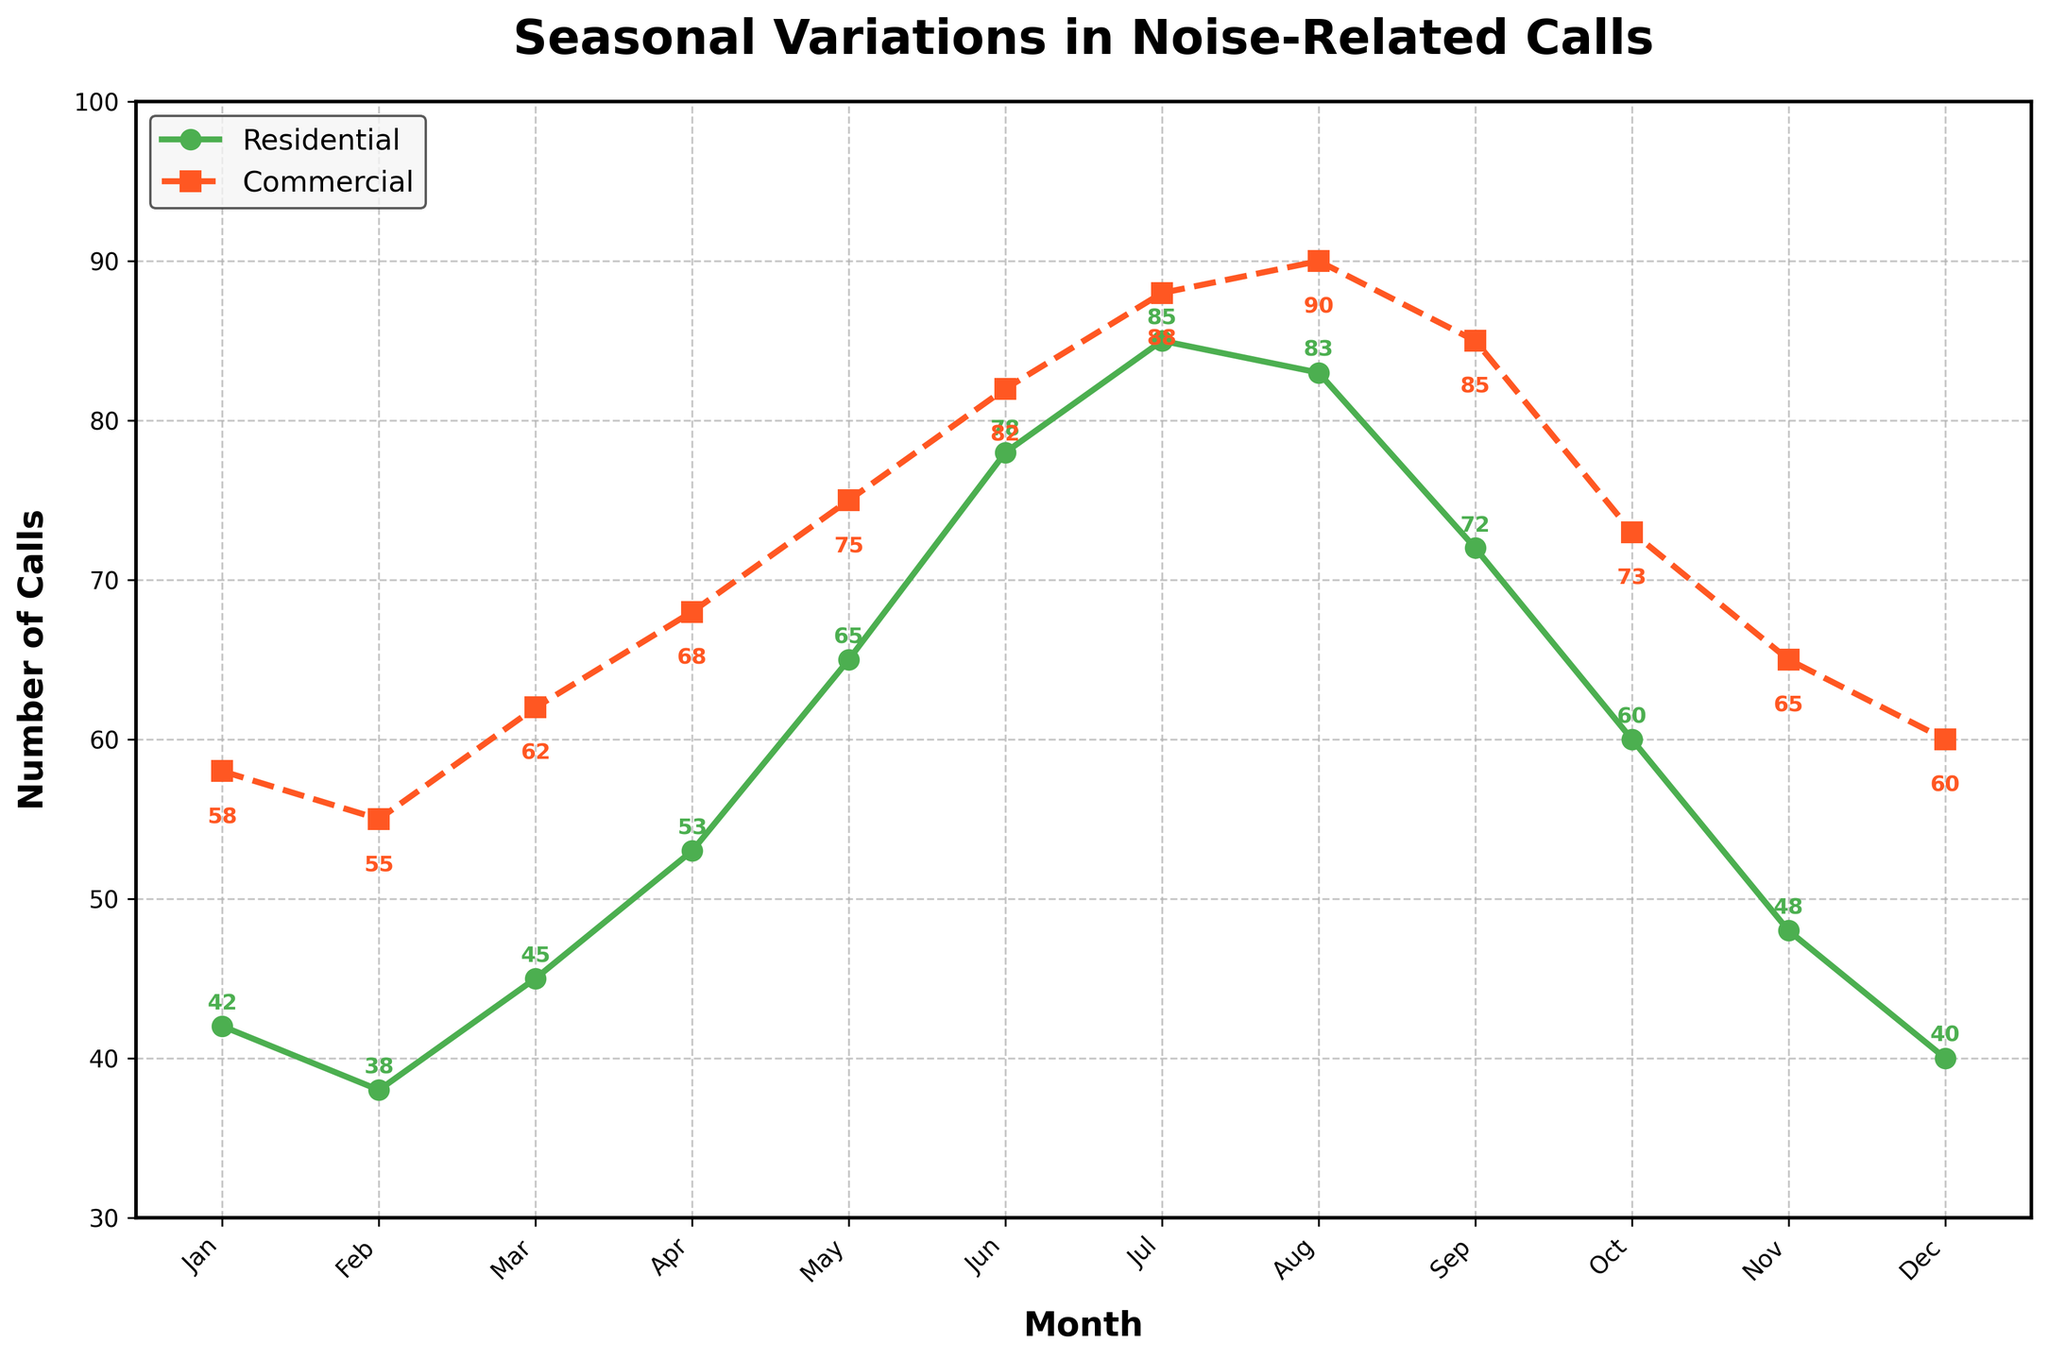Which month has the highest number of noise-related calls in residential areas? To find the highest number of noise-related calls in residential areas, look for the peak point on the green line labeled "Residential." The peak occurs in July.
Answer: July In which month is the difference between residential and commercial noise-related calls the smallest? To determine the smallest difference, calculate the differences between residential and commercial calls for each month: Jan (16), Feb (17), Mar (17), Apr (15), May (10), Jun (4), Jul (3), Aug (7), Sep (13), Oct (13), Nov (17), Dec (20). The smallest difference is in July (3).
Answer: July Compare the number of noise-related calls in May: Are there more calls from residential or commercial areas? To answer this, compare the values for May in both categories. Residential has 65 calls and Commercial has 75 calls. Since 75 is greater than 65, there are more calls in commercial areas in May.
Answer: Commercial What is the average number of noise-related calls in commercial areas over the year? Add all the monthly call counts in commercial areas and divide by 12 months: (58+55+62+68+75+82+88+90+85+73+65+60) / 12 = 851 / 12 ≈ 70.92.
Answer: 70.92 During which month did the residential areas see the most significant increase in noise-related calls compared to the previous month? Calculate the differences between consecutive months in residential areas to identify the maximum increase: Feb (3), Mar (7), Apr (8), May (12), Jun (13), Jul (7), Aug (-2), Sep (-11), Oct (-12), Nov (-12), Dec (-8). The most significant increase occurred from May to June (13).
Answer: June In which months do both residential and commercial areas have fewer than 50 noise-related calls? Identify months where both values are less than 50: Jan (Residential: 42, Commercial: 58), Feb (Residential: 38, Commercial: 55), Mar (Residential: 45, Commercial: 62), Apr (Residential: 53, Commercial: 68), May (Residential: 65, Commercial: 75), Jun (Residential: 78, Commercial: 82), Jul (Residential: 85, Commercial: 88), Aug (Residential: 83, Commercial: 90), Sep (Residential: 72, Commercial: 85), Oct (Residential: 60, Commercial: 73), Nov (Residential: 48, Commercial: 65), Dec (Residential: 40, Commercial: 60). Only Feb has both values below 50.
Answer: February Which month has the steepest drop in noise-related calls in residential areas? Calculate the differences between consecutive months to find the steepest drop: Feb (4), Mar (-7), Apr (-8), May (-12), Jun (-13), Jul (-7), Aug (2), Sep (11), Oct (12), Nov (12), Dec (8). The steepest drop occurs from Aug to Sep (-11).
Answer: September What is the range of noise-related calls in commercial areas? To find the range, subtract the smallest value in commercial areas from the largest value: Max (90) - Min (55) = 35.
Answer: 35 